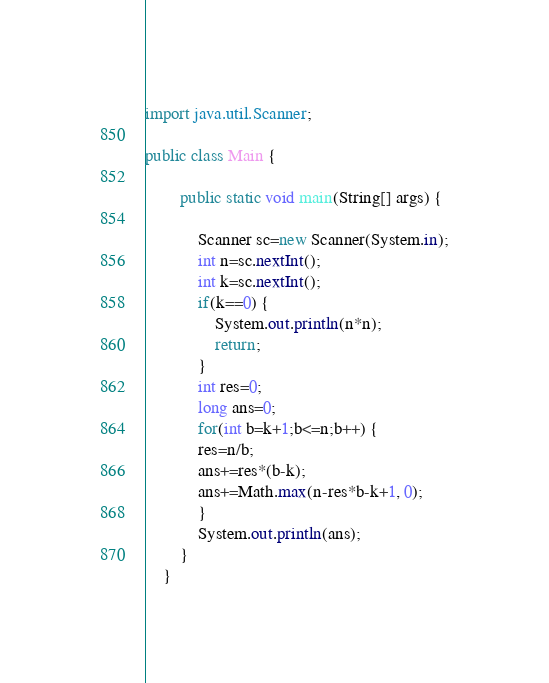Convert code to text. <code><loc_0><loc_0><loc_500><loc_500><_Java_>import java.util.Scanner;

public class Main {

		public static void main(String[] args) {

			Scanner sc=new Scanner(System.in);
			int n=sc.nextInt();
			int k=sc.nextInt();
			if(k==0) {
				System.out.println(n*n);
				return;
			}
			int res=0;
			long ans=0;
			for(int b=k+1;b<=n;b++) {
			res=n/b;
			ans+=res*(b-k);
			ans+=Math.max(n-res*b-k+1, 0);
			}
			System.out.println(ans);
		}
	}

</code> 